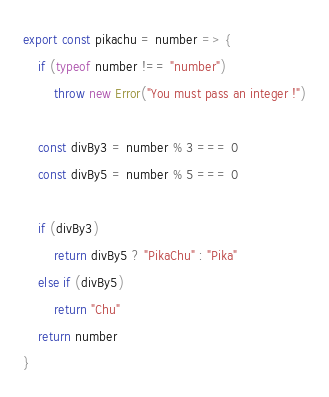Convert code to text. <code><loc_0><loc_0><loc_500><loc_500><_JavaScript_>export const pikachu = number => {
    if (typeof number !== "number")
        throw new Error("You must pass an integer !")

    const divBy3 = number % 3 === 0
    const divBy5 = number % 5 === 0

    if (divBy3)
        return divBy5 ? "PikaChu" : "Pika"
    else if (divBy5)
        return "Chu"
    return number
}</code> 